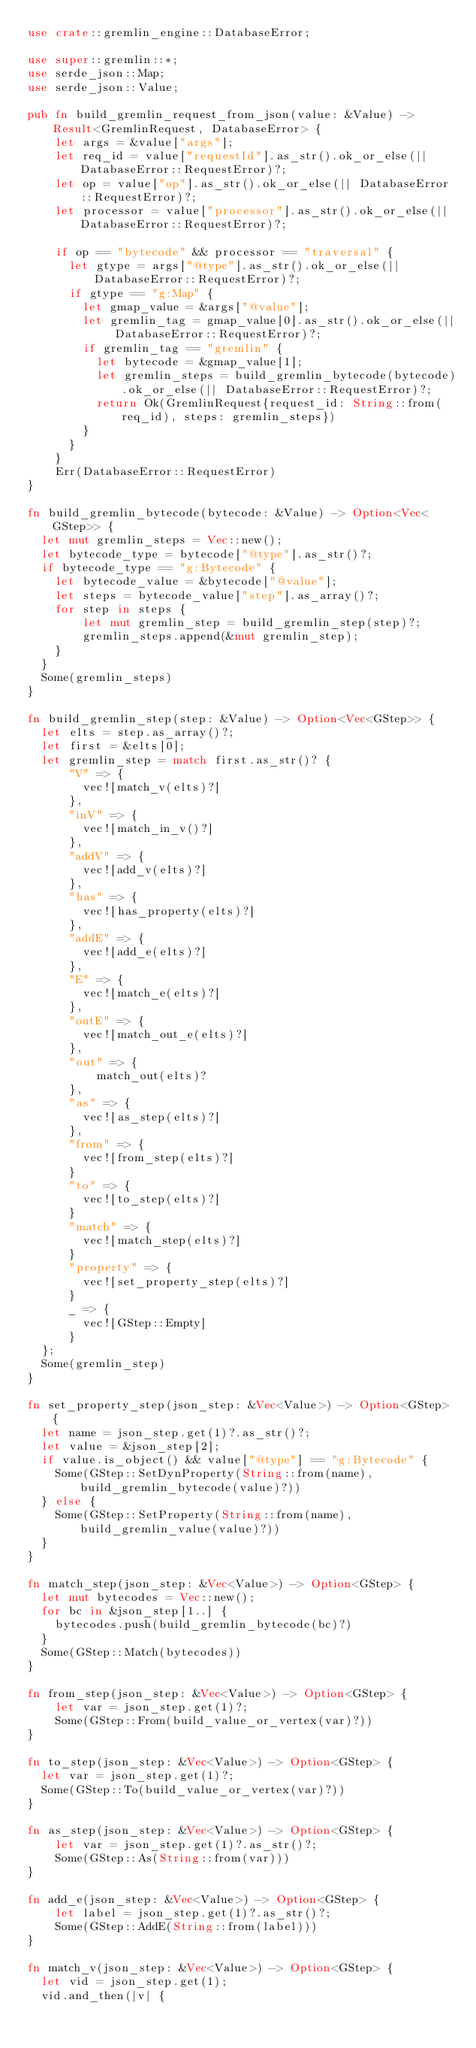<code> <loc_0><loc_0><loc_500><loc_500><_Rust_>use crate::gremlin_engine::DatabaseError;

use super::gremlin::*;
use serde_json::Map;
use serde_json::Value;

pub fn build_gremlin_request_from_json(value: &Value) -> Result<GremlinRequest, DatabaseError> {
    let args = &value["args"];
    let req_id = value["requestId"].as_str().ok_or_else(|| DatabaseError::RequestError)?;
    let op = value["op"].as_str().ok_or_else(|| DatabaseError::RequestError)?;
    let processor = value["processor"].as_str().ok_or_else(|| DatabaseError::RequestError)?;
    
    if op == "bytecode" && processor == "traversal" {
      let gtype = args["@type"].as_str().ok_or_else(|| DatabaseError::RequestError)?;
      if gtype == "g:Map" {
        let gmap_value = &args["@value"];
        let gremlin_tag = gmap_value[0].as_str().ok_or_else(|| DatabaseError::RequestError)?;
        if gremlin_tag == "gremlin" {
          let bytecode = &gmap_value[1];
          let gremlin_steps = build_gremlin_bytecode(bytecode).ok_or_else(|| DatabaseError::RequestError)?;
          return Ok(GremlinRequest{request_id: String::from(req_id), steps: gremlin_steps})
        }
      }
    }
    Err(DatabaseError::RequestError)
}

fn build_gremlin_bytecode(bytecode: &Value) -> Option<Vec<GStep>> {
  let mut gremlin_steps = Vec::new();
  let bytecode_type = bytecode["@type"].as_str()?;
  if bytecode_type == "g:Bytecode" {
    let bytecode_value = &bytecode["@value"];
    let steps = bytecode_value["step"].as_array()?;
    for step in steps {
        let mut gremlin_step = build_gremlin_step(step)?;
        gremlin_steps.append(&mut gremlin_step);
    }
  }
  Some(gremlin_steps)
}

fn build_gremlin_step(step: &Value) -> Option<Vec<GStep>> {
  let elts = step.as_array()?;
  let first = &elts[0];
  let gremlin_step = match first.as_str()? {
      "V" => {
        vec![match_v(elts)?]
      },
      "inV" => {
        vec![match_in_v()?]
      },
      "addV" => {
        vec![add_v(elts)?]
      },
      "has" => {
        vec![has_property(elts)?]
      },
      "addE" => {
        vec![add_e(elts)?]
      },
      "E" => {
        vec![match_e(elts)?]
      },
      "outE" => {
        vec![match_out_e(elts)?]
      },
      "out" => {
          match_out(elts)?
      },
      "as" => {
        vec![as_step(elts)?]
      },
      "from" => {
        vec![from_step(elts)?]
      }
      "to" => {
        vec![to_step(elts)?]
      }
      "match" => {
        vec![match_step(elts)?]
      }
      "property" => {
        vec![set_property_step(elts)?]
      }
      _ => {
        vec![GStep::Empty]
      }
  };
  Some(gremlin_step)
}

fn set_property_step(json_step: &Vec<Value>) -> Option<GStep> {
  let name = json_step.get(1)?.as_str()?;
  let value = &json_step[2];
  if value.is_object() && value["@type"] == "g:Bytecode" {
    Some(GStep::SetDynProperty(String::from(name), build_gremlin_bytecode(value)?))
  } else {
    Some(GStep::SetProperty(String::from(name), build_gremlin_value(value)?))
  }  
}

fn match_step(json_step: &Vec<Value>) -> Option<GStep> {
  let mut bytecodes = Vec::new();
  for bc in &json_step[1..] {
    bytecodes.push(build_gremlin_bytecode(bc)?)
  } 
  Some(GStep::Match(bytecodes))
}

fn from_step(json_step: &Vec<Value>) -> Option<GStep> {
    let var = json_step.get(1)?;
    Some(GStep::From(build_value_or_vertex(var)?))
}

fn to_step(json_step: &Vec<Value>) -> Option<GStep> {
  let var = json_step.get(1)?;
  Some(GStep::To(build_value_or_vertex(var)?))
}

fn as_step(json_step: &Vec<Value>) -> Option<GStep> {
    let var = json_step.get(1)?.as_str()?;
    Some(GStep::As(String::from(var)))
}

fn add_e(json_step: &Vec<Value>) -> Option<GStep> {
    let label = json_step.get(1)?.as_str()?;
    Some(GStep::AddE(String::from(label)))
}

fn match_v(json_step: &Vec<Value>) -> Option<GStep> {
  let vid = json_step.get(1);
  vid.and_then(|v| {</code> 